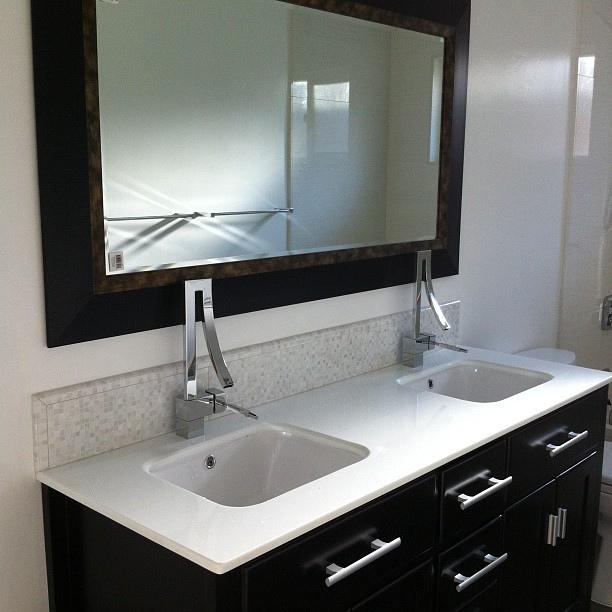What's unusual about this set up?
Be succinct. Faucets. Is this bathroom a showpiece?
Answer briefly. Yes. Is there any soap here?
Give a very brief answer. No. Is there a hair dryer in the room?
Be succinct. No. 